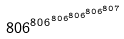<formula> <loc_0><loc_0><loc_500><loc_500>8 0 6 ^ { 8 0 6 ^ { 8 0 6 ^ { 8 0 6 ^ { 8 0 6 ^ { 8 0 7 } } } } }</formula> 